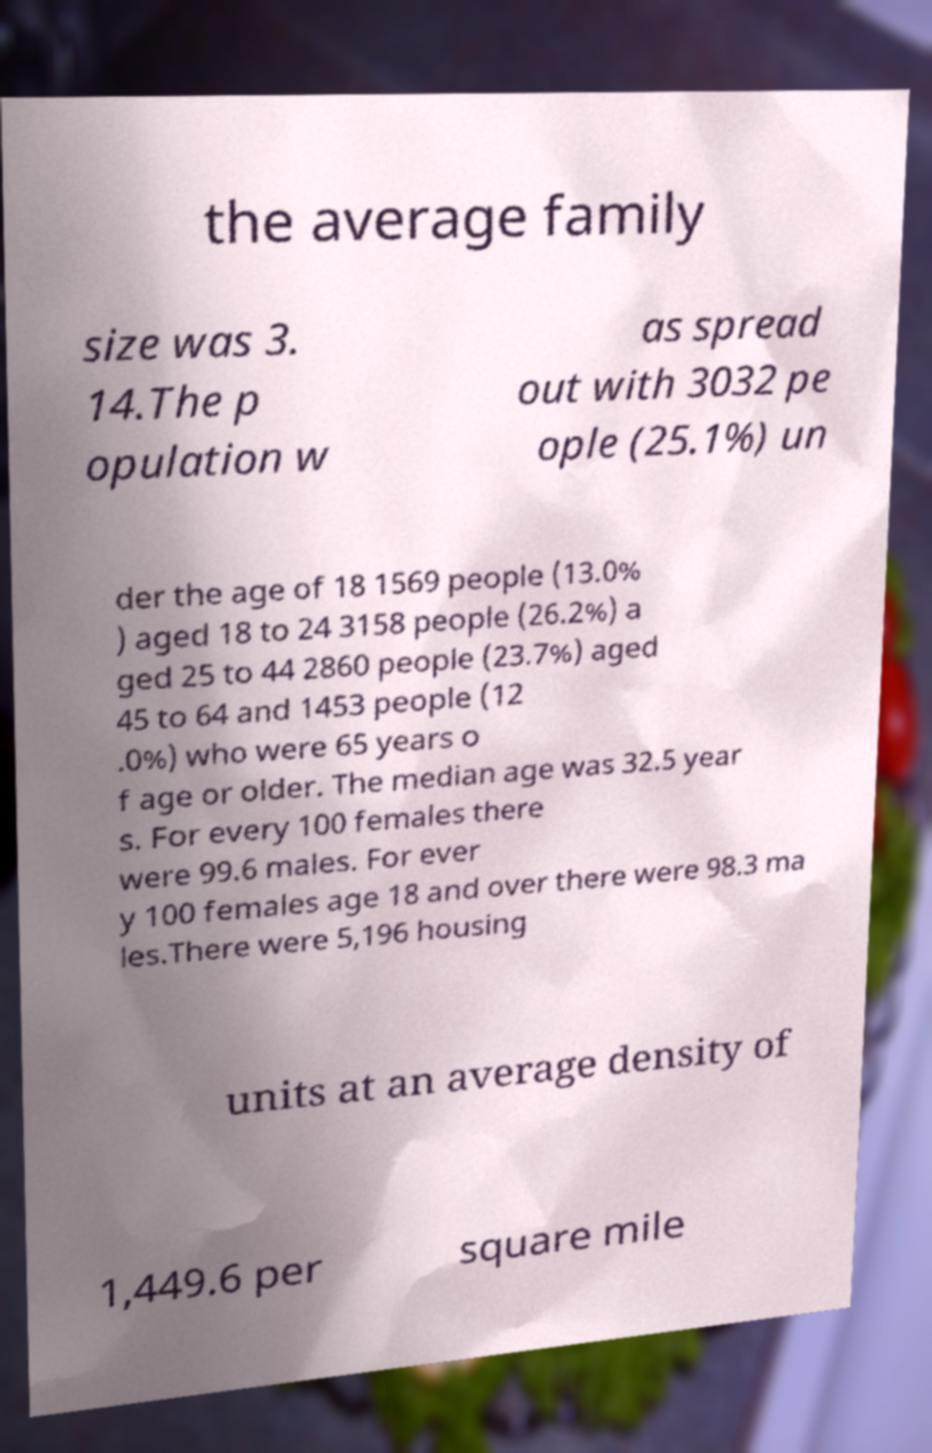For documentation purposes, I need the text within this image transcribed. Could you provide that? the average family size was 3. 14.The p opulation w as spread out with 3032 pe ople (25.1%) un der the age of 18 1569 people (13.0% ) aged 18 to 24 3158 people (26.2%) a ged 25 to 44 2860 people (23.7%) aged 45 to 64 and 1453 people (12 .0%) who were 65 years o f age or older. The median age was 32.5 year s. For every 100 females there were 99.6 males. For ever y 100 females age 18 and over there were 98.3 ma les.There were 5,196 housing units at an average density of 1,449.6 per square mile 